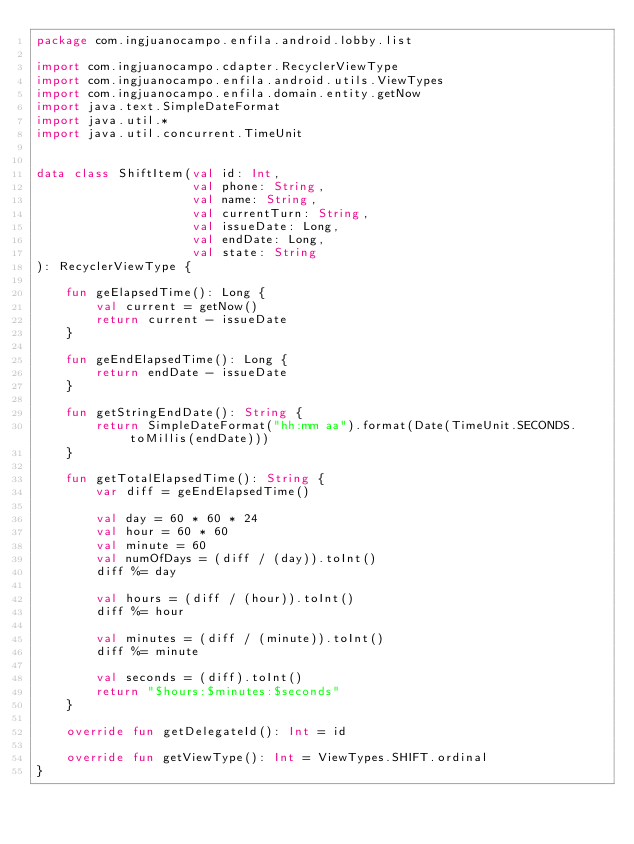Convert code to text. <code><loc_0><loc_0><loc_500><loc_500><_Kotlin_>package com.ingjuanocampo.enfila.android.lobby.list

import com.ingjuanocampo.cdapter.RecyclerViewType
import com.ingjuanocampo.enfila.android.utils.ViewTypes
import com.ingjuanocampo.enfila.domain.entity.getNow
import java.text.SimpleDateFormat
import java.util.*
import java.util.concurrent.TimeUnit


data class ShiftItem(val id: Int,
                     val phone: String,
                     val name: String,
                     val currentTurn: String,
                     val issueDate: Long,
                     val endDate: Long,
                     val state: String
): RecyclerViewType {

    fun geElapsedTime(): Long {
        val current = getNow()
        return current - issueDate
    }

    fun geEndElapsedTime(): Long {
        return endDate - issueDate
    }

    fun getStringEndDate(): String {
        return SimpleDateFormat("hh:mm aa").format(Date(TimeUnit.SECONDS.toMillis(endDate)))
    }

    fun getTotalElapsedTime(): String {
        var diff = geEndElapsedTime()

        val day = 60 * 60 * 24
        val hour = 60 * 60
        val minute = 60
        val numOfDays = (diff / (day)).toInt()
        diff %= day

        val hours = (diff / (hour)).toInt()
        diff %= hour

        val minutes = (diff / (minute)).toInt()
        diff %= minute

        val seconds = (diff).toInt()
        return "$hours:$minutes:$seconds"
    }

    override fun getDelegateId(): Int = id

    override fun getViewType(): Int = ViewTypes.SHIFT.ordinal
}</code> 